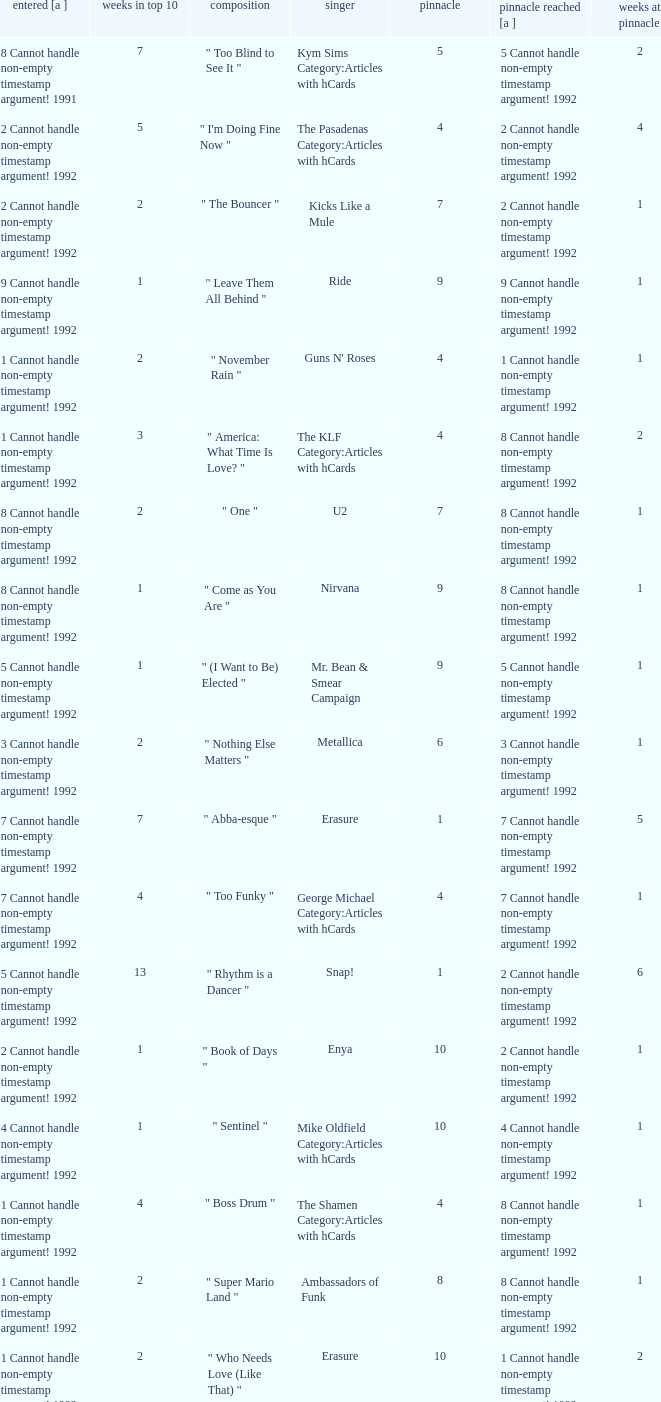What was the peak reached for a single with 4 weeks in the top 10 and entered in 7 cannot handle non-empty timestamp argument! 1992? 7 Cannot handle non-empty timestamp argument! 1992. 